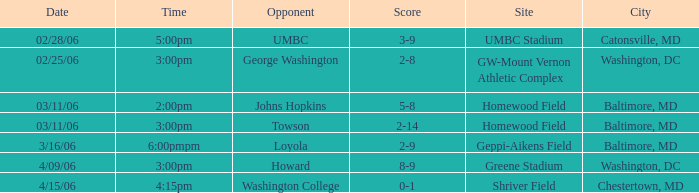Which Score has a Time of 5:00pm? 3-9. 